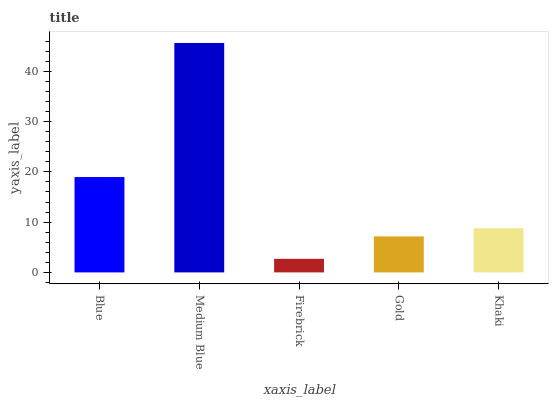Is Firebrick the minimum?
Answer yes or no. Yes. Is Medium Blue the maximum?
Answer yes or no. Yes. Is Medium Blue the minimum?
Answer yes or no. No. Is Firebrick the maximum?
Answer yes or no. No. Is Medium Blue greater than Firebrick?
Answer yes or no. Yes. Is Firebrick less than Medium Blue?
Answer yes or no. Yes. Is Firebrick greater than Medium Blue?
Answer yes or no. No. Is Medium Blue less than Firebrick?
Answer yes or no. No. Is Khaki the high median?
Answer yes or no. Yes. Is Khaki the low median?
Answer yes or no. Yes. Is Blue the high median?
Answer yes or no. No. Is Medium Blue the low median?
Answer yes or no. No. 